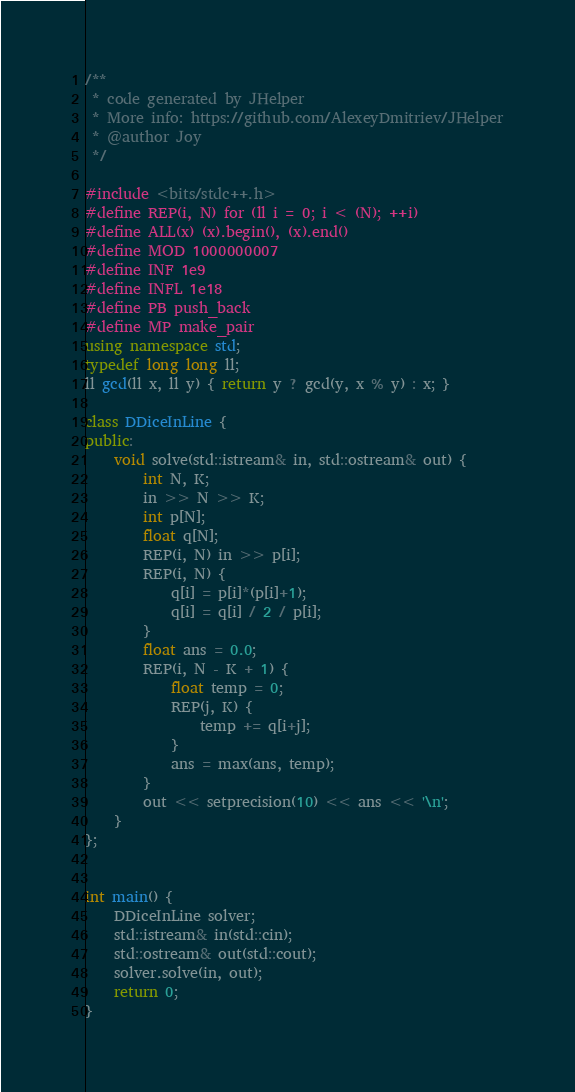<code> <loc_0><loc_0><loc_500><loc_500><_C++_>/**
 * code generated by JHelper
 * More info: https://github.com/AlexeyDmitriev/JHelper
 * @author Joy
 */

#include <bits/stdc++.h>
#define REP(i, N) for (ll i = 0; i < (N); ++i)
#define ALL(x) (x).begin(), (x).end()
#define MOD 1000000007
#define INF 1e9
#define INFL 1e18
#define PB push_back
#define MP make_pair
using namespace std;
typedef long long ll;
ll gcd(ll x, ll y) { return y ? gcd(y, x % y) : x; }

class DDiceInLine {
public:
	void solve(std::istream& in, std::ostream& out) {
	    int N, K;
        in >> N >> K;
        int p[N];
        float q[N];
        REP(i, N) in >> p[i];
        REP(i, N) {
            q[i] = p[i]*(p[i]+1);
            q[i] = q[i] / 2 / p[i];
        }
        float ans = 0.0;
        REP(i, N - K + 1) {
            float temp = 0;
            REP(j, K) {
                temp += q[i+j];
            }
            ans = max(ans, temp);
        }
        out << setprecision(10) << ans << '\n';
	}
};


int main() {
	DDiceInLine solver;
	std::istream& in(std::cin);
	std::ostream& out(std::cout);
	solver.solve(in, out);
	return 0;
}
</code> 